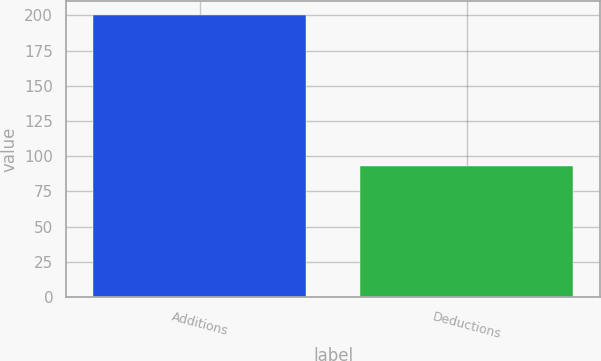Convert chart to OTSL. <chart><loc_0><loc_0><loc_500><loc_500><bar_chart><fcel>Additions<fcel>Deductions<nl><fcel>200<fcel>93<nl></chart> 